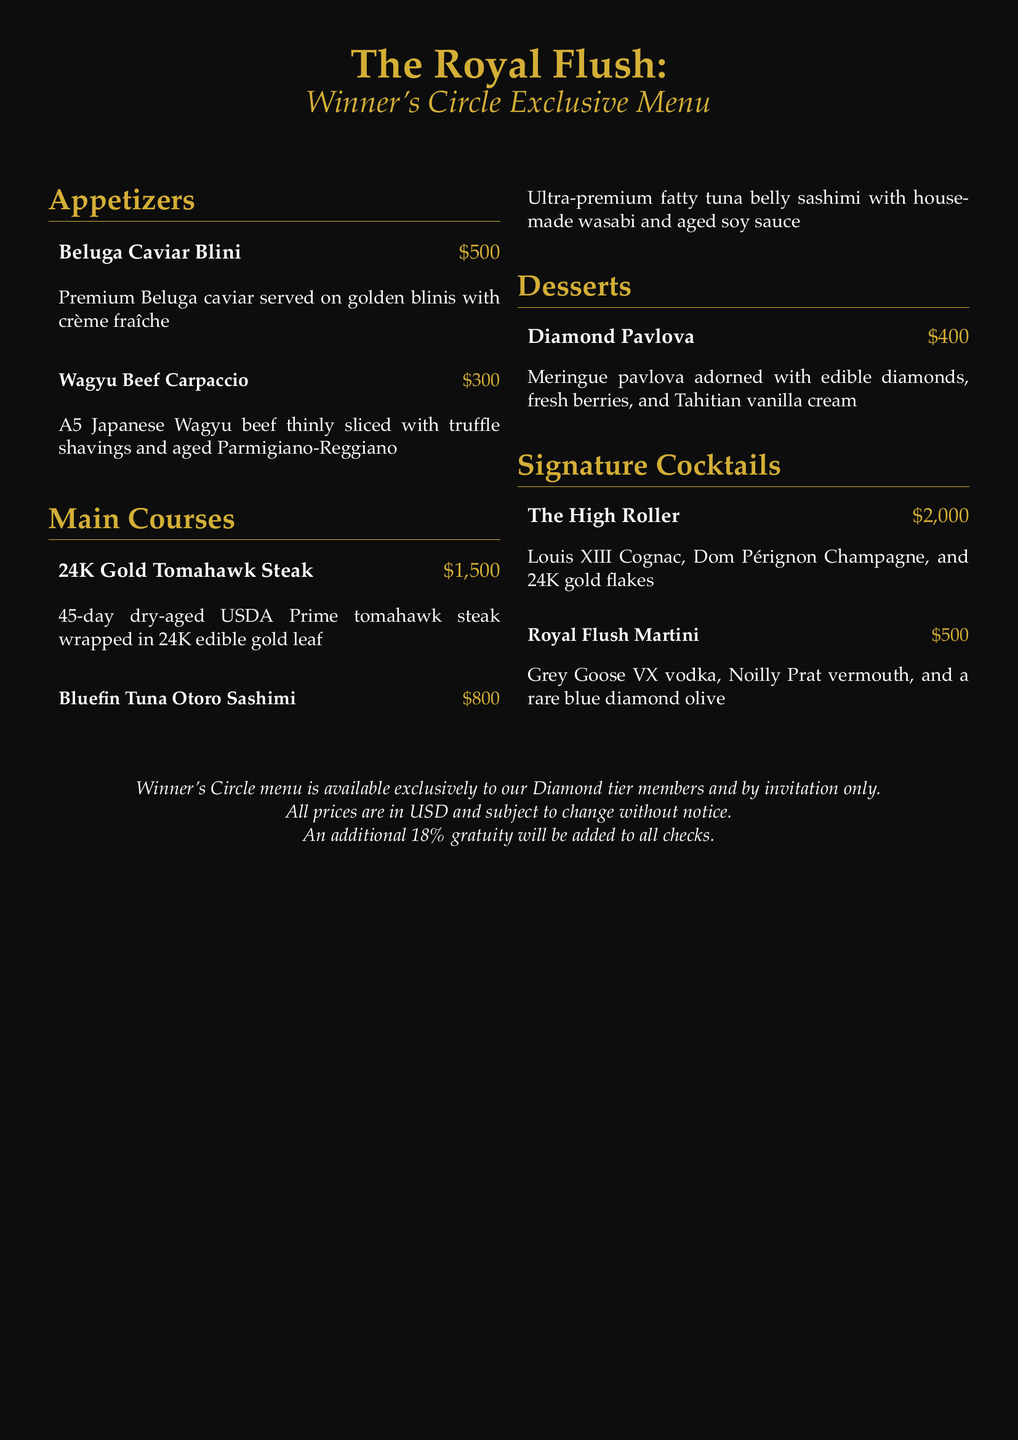What is the most expensive appetizer? The most expensive appetizer is listed in the menu as Beluga Caviar Blini for $500.
Answer: Beluga Caviar Blini How much does the 24K Gold Tomahawk Steak cost? The cost of the 24K Gold Tomahawk Steak is specifically mentioned as $1,500 in the menu.
Answer: $1,500 What type of vodka is used in The Royal Flush Martini? The menu states that Grey Goose VX vodka is used in The Royal Flush Martini.
Answer: Grey Goose VX How many desserts are listed on the Winner's Circle menu? There is one dessert mentioned in the document, which is the Diamond Pavlova.
Answer: One What is the total cost of the appetizers on the menu? The total cost includes $500 for Beluga Caviar Blini and $300 for Wagyu Beef Carpaccio, which sums up to $800.
Answer: $800 Is the Winner's Circle menu available to all guests? The menu specifies that it is available exclusively to Diamond tier members and by invitation only.
Answer: No What is the unique feature of the Diamond Pavlova? The unique feature highlighted in the document is that it is adorned with edible diamonds.
Answer: Edible diamonds What ingredient gives The High Roller cocktail its luxury? The luxury element mentioned for The High Roller is the inclusion of Louis XIII Cognac.
Answer: Louis XIII Cognac 